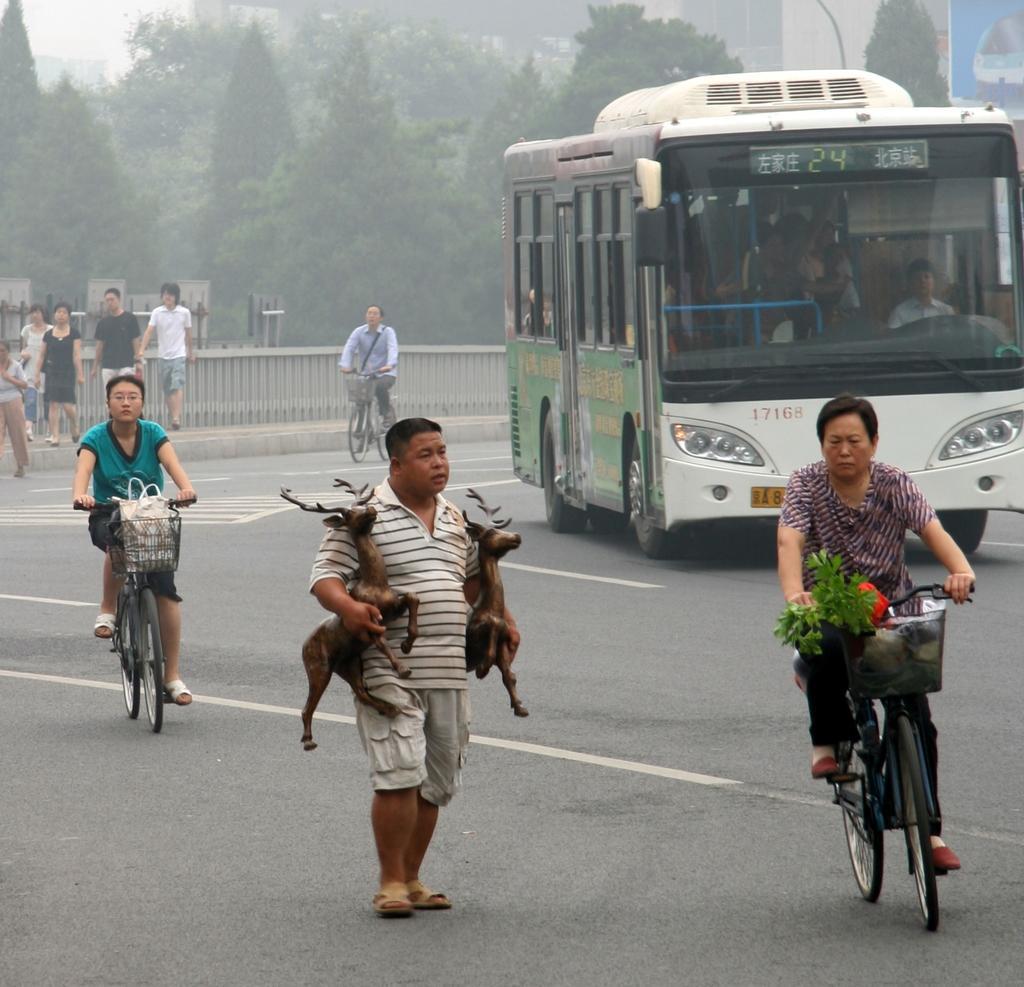How would you summarize this image in a sentence or two? This a road. In road there is a bus. One person is walking wearing a white t shirt and shorts. He is holding two statues of deer. One person is riding a bicycle. In the basket there is some leaves. One woman is also riding a bicycle. There is a plastic bag in the basket of the bicycle. Some people are walking in the side lane. There is boundary in the side of the road. There are trees in the background. There is a building in the background. Another person is riding the bicycle is carrying a shoulder bag. 